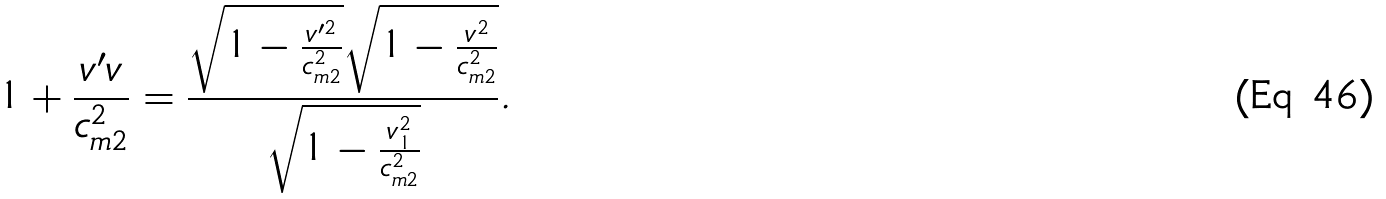<formula> <loc_0><loc_0><loc_500><loc_500>1 + \frac { v ^ { \prime } v } { c _ { m 2 } ^ { 2 } } = \frac { \sqrt { 1 - \frac { v ^ { \prime 2 } } { c _ { m 2 } ^ { 2 } } } \sqrt { 1 - \frac { v ^ { 2 } } { c _ { m 2 } ^ { 2 } } } } { \sqrt { 1 - \frac { v _ { 1 } ^ { 2 } } { c _ { m 2 } ^ { 2 } } } } .</formula> 